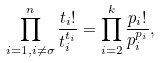<formula> <loc_0><loc_0><loc_500><loc_500>\prod _ { i = 1 , i \neq \sigma } ^ { n } \frac { t _ { i } ! } { t _ { i } ^ { t _ { i } } } = \prod _ { i = 2 } ^ { k } \frac { p _ { i } ! } { p _ { i } ^ { p _ { i } } } ,</formula> 